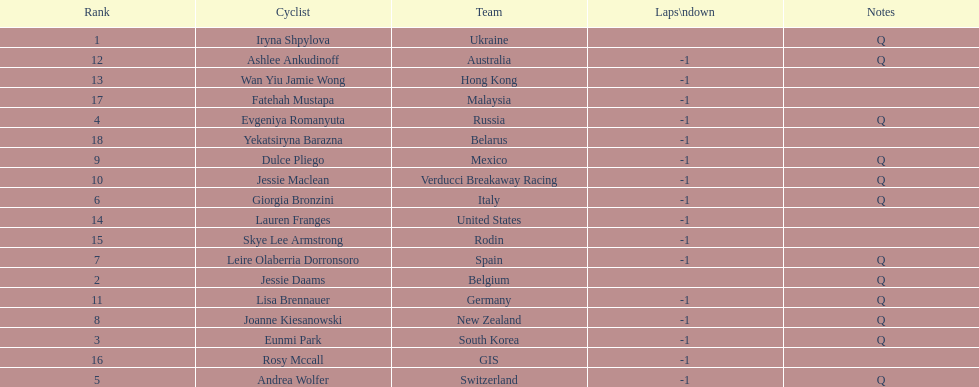Who was the top ranked competitor in this race? Iryna Shpylova. 